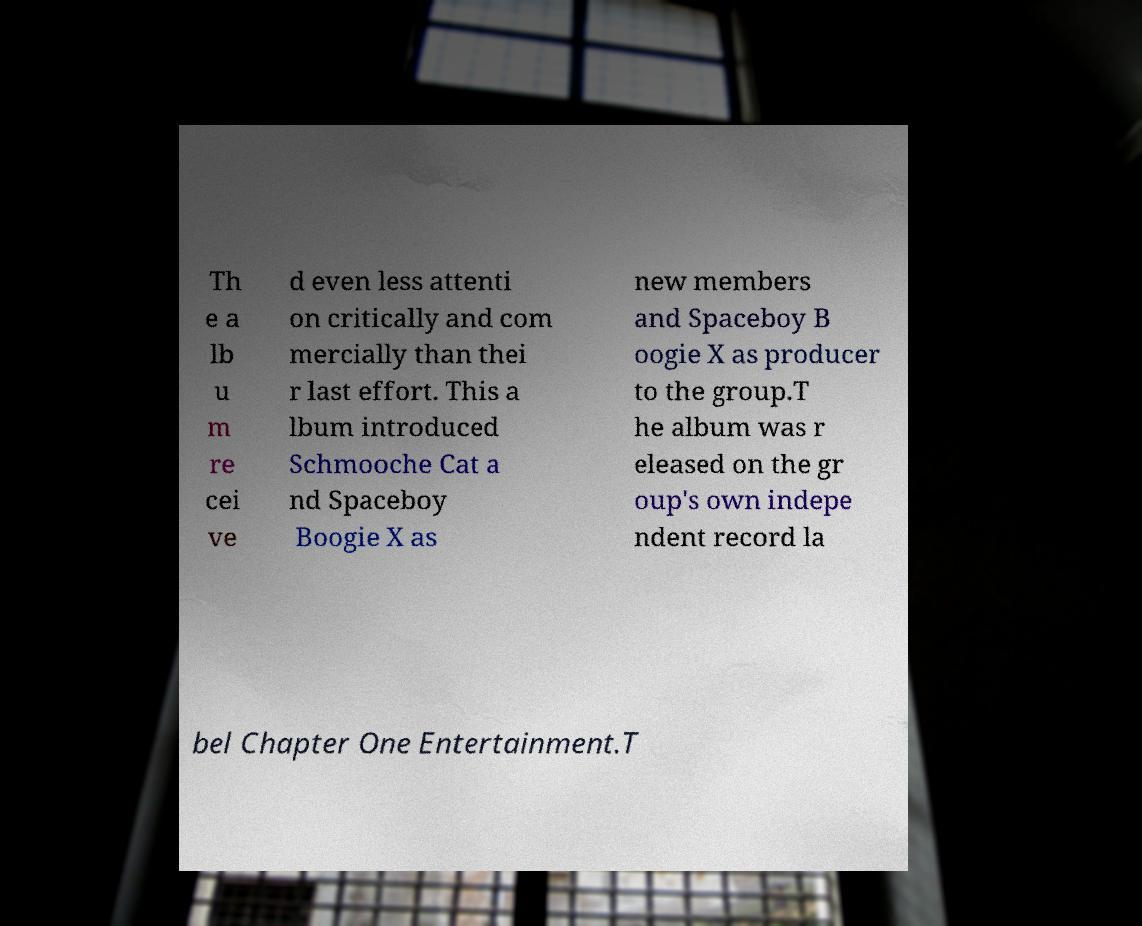Please read and relay the text visible in this image. What does it say? Th e a lb u m re cei ve d even less attenti on critically and com mercially than thei r last effort. This a lbum introduced Schmooche Cat a nd Spaceboy Boogie X as new members and Spaceboy B oogie X as producer to the group.T he album was r eleased on the gr oup's own indepe ndent record la bel Chapter One Entertainment.T 